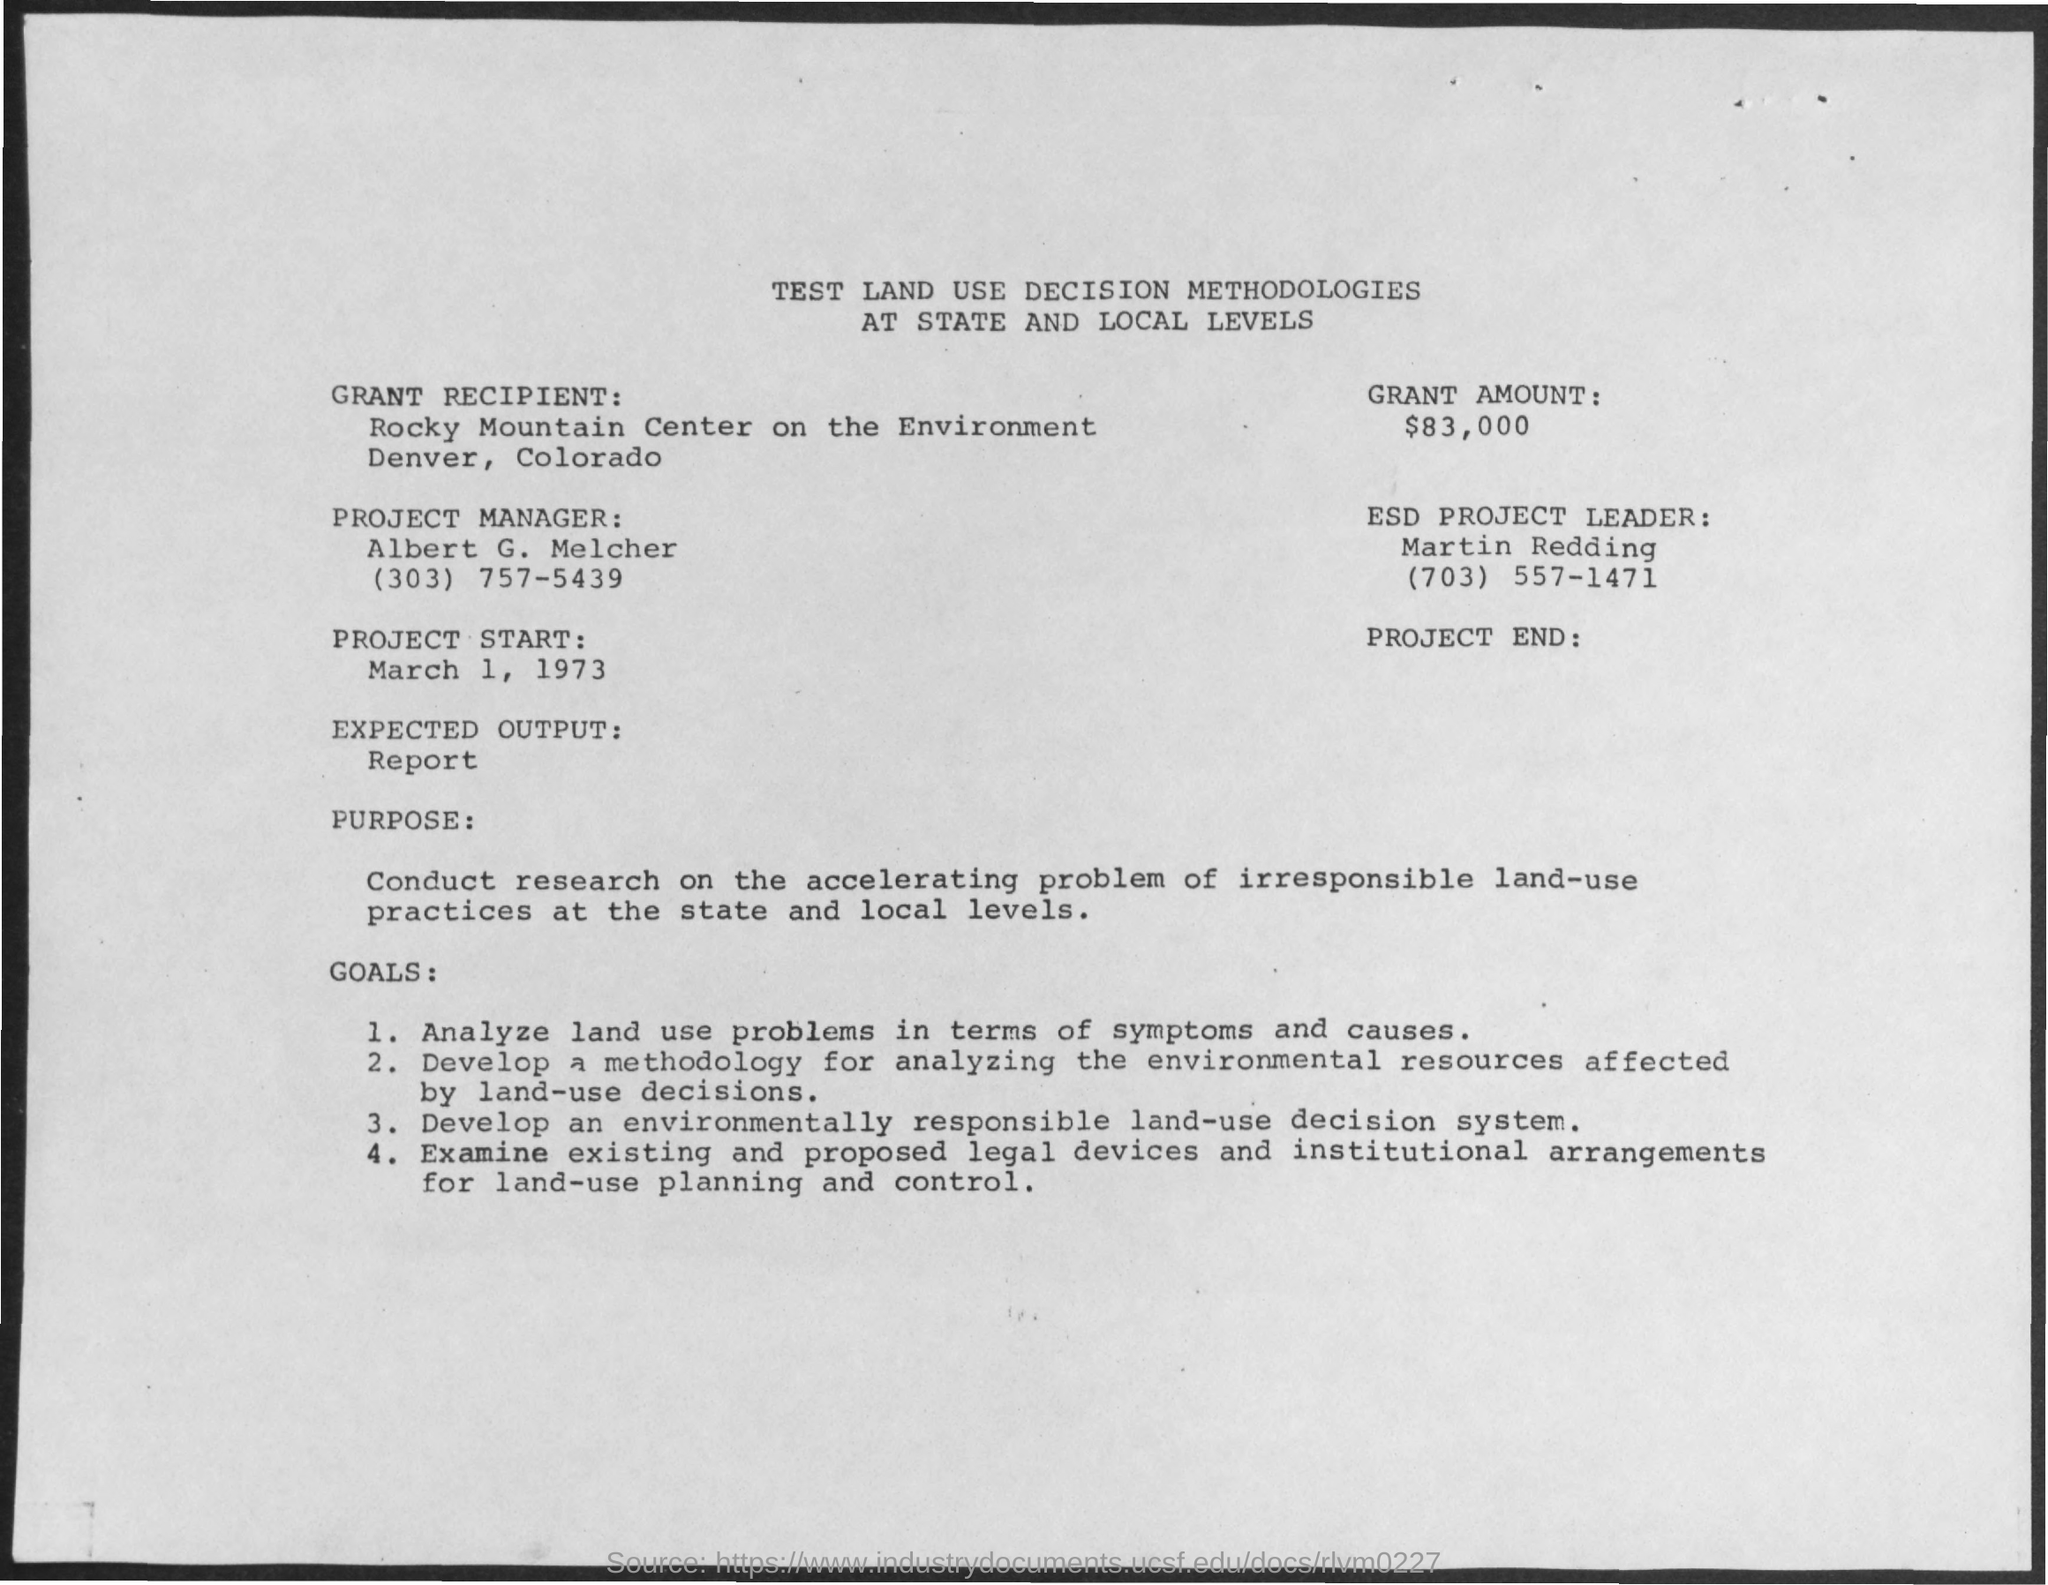What is the date of project start?
Offer a terse response. March 1 , 1973. Who is the project manager ?
Keep it short and to the point. Albert G. Melcher. In which  state & city grant recipient located ?
Your answer should be very brief. Denver, Colorado. What is the contact number of project manager ?
Offer a terse response. (303) 757-5439. What is the contact number of esd project leader ?
Provide a short and direct response. (703)  557-1471. What is the expected output ?
Offer a very short reply. Report. 